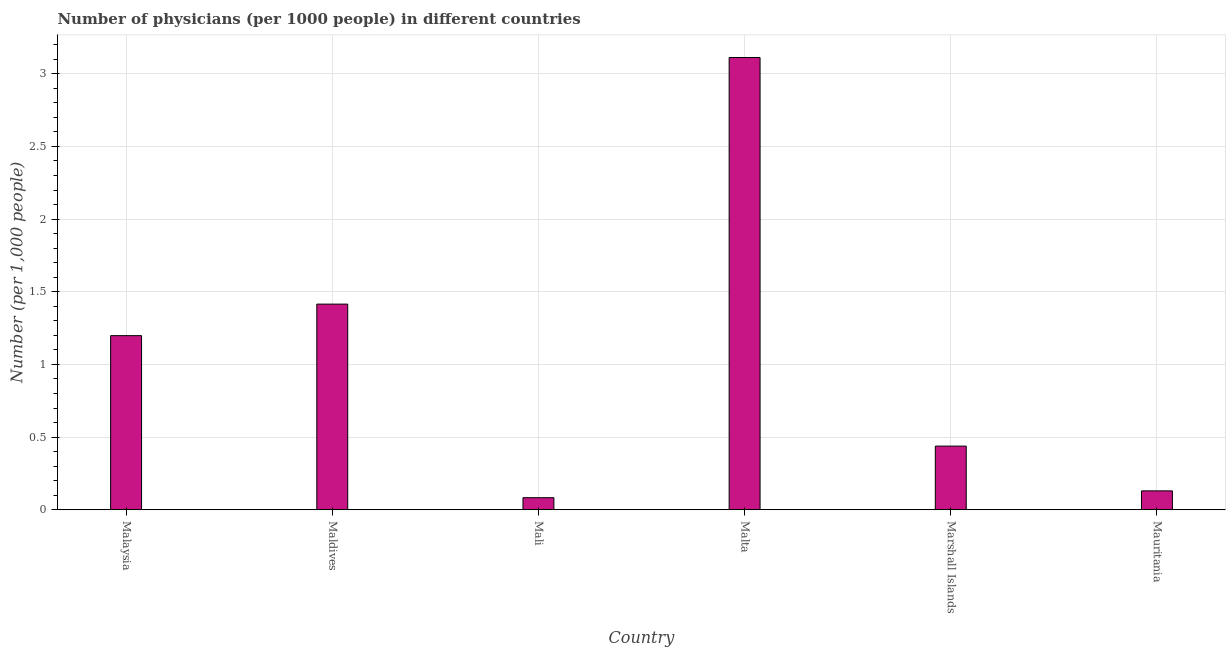Does the graph contain any zero values?
Your answer should be compact. No. What is the title of the graph?
Make the answer very short. Number of physicians (per 1000 people) in different countries. What is the label or title of the Y-axis?
Provide a succinct answer. Number (per 1,0 people). What is the number of physicians in Maldives?
Give a very brief answer. 1.42. Across all countries, what is the maximum number of physicians?
Your response must be concise. 3.11. Across all countries, what is the minimum number of physicians?
Your answer should be compact. 0.08. In which country was the number of physicians maximum?
Provide a short and direct response. Malta. In which country was the number of physicians minimum?
Provide a short and direct response. Mali. What is the sum of the number of physicians?
Make the answer very short. 6.38. What is the difference between the number of physicians in Mali and Malta?
Make the answer very short. -3.03. What is the average number of physicians per country?
Your answer should be very brief. 1.06. What is the median number of physicians?
Offer a terse response. 0.82. In how many countries, is the number of physicians greater than 2.8 ?
Your answer should be compact. 1. What is the ratio of the number of physicians in Marshall Islands to that in Mauritania?
Provide a short and direct response. 3.37. Is the difference between the number of physicians in Maldives and Mali greater than the difference between any two countries?
Keep it short and to the point. No. What is the difference between the highest and the second highest number of physicians?
Keep it short and to the point. 1.7. What is the difference between the highest and the lowest number of physicians?
Your answer should be very brief. 3.03. Are the values on the major ticks of Y-axis written in scientific E-notation?
Offer a terse response. No. What is the Number (per 1,000 people) of Malaysia?
Give a very brief answer. 1.2. What is the Number (per 1,000 people) of Maldives?
Your answer should be compact. 1.42. What is the Number (per 1,000 people) in Mali?
Provide a short and direct response. 0.08. What is the Number (per 1,000 people) in Malta?
Give a very brief answer. 3.11. What is the Number (per 1,000 people) in Marshall Islands?
Your answer should be compact. 0.44. What is the Number (per 1,000 people) of Mauritania?
Your answer should be very brief. 0.13. What is the difference between the Number (per 1,000 people) in Malaysia and Maldives?
Make the answer very short. -0.22. What is the difference between the Number (per 1,000 people) in Malaysia and Mali?
Make the answer very short. 1.11. What is the difference between the Number (per 1,000 people) in Malaysia and Malta?
Keep it short and to the point. -1.91. What is the difference between the Number (per 1,000 people) in Malaysia and Marshall Islands?
Your answer should be compact. 0.76. What is the difference between the Number (per 1,000 people) in Malaysia and Mauritania?
Keep it short and to the point. 1.07. What is the difference between the Number (per 1,000 people) in Maldives and Mali?
Your answer should be compact. 1.33. What is the difference between the Number (per 1,000 people) in Maldives and Malta?
Your response must be concise. -1.7. What is the difference between the Number (per 1,000 people) in Maldives and Marshall Islands?
Offer a terse response. 0.98. What is the difference between the Number (per 1,000 people) in Maldives and Mauritania?
Provide a short and direct response. 1.28. What is the difference between the Number (per 1,000 people) in Mali and Malta?
Make the answer very short. -3.03. What is the difference between the Number (per 1,000 people) in Mali and Marshall Islands?
Keep it short and to the point. -0.35. What is the difference between the Number (per 1,000 people) in Mali and Mauritania?
Provide a succinct answer. -0.05. What is the difference between the Number (per 1,000 people) in Malta and Marshall Islands?
Give a very brief answer. 2.67. What is the difference between the Number (per 1,000 people) in Malta and Mauritania?
Provide a succinct answer. 2.98. What is the difference between the Number (per 1,000 people) in Marshall Islands and Mauritania?
Keep it short and to the point. 0.31. What is the ratio of the Number (per 1,000 people) in Malaysia to that in Maldives?
Make the answer very short. 0.85. What is the ratio of the Number (per 1,000 people) in Malaysia to that in Mali?
Provide a succinct answer. 14.43. What is the ratio of the Number (per 1,000 people) in Malaysia to that in Malta?
Make the answer very short. 0.39. What is the ratio of the Number (per 1,000 people) in Malaysia to that in Marshall Islands?
Keep it short and to the point. 2.73. What is the ratio of the Number (per 1,000 people) in Malaysia to that in Mauritania?
Provide a succinct answer. 9.21. What is the ratio of the Number (per 1,000 people) in Maldives to that in Mali?
Provide a succinct answer. 17.05. What is the ratio of the Number (per 1,000 people) in Maldives to that in Malta?
Give a very brief answer. 0.46. What is the ratio of the Number (per 1,000 people) in Maldives to that in Marshall Islands?
Your response must be concise. 3.23. What is the ratio of the Number (per 1,000 people) in Maldives to that in Mauritania?
Ensure brevity in your answer.  10.88. What is the ratio of the Number (per 1,000 people) in Mali to that in Malta?
Your response must be concise. 0.03. What is the ratio of the Number (per 1,000 people) in Mali to that in Marshall Islands?
Make the answer very short. 0.19. What is the ratio of the Number (per 1,000 people) in Mali to that in Mauritania?
Ensure brevity in your answer.  0.64. What is the ratio of the Number (per 1,000 people) in Malta to that in Marshall Islands?
Offer a terse response. 7.11. What is the ratio of the Number (per 1,000 people) in Malta to that in Mauritania?
Your answer should be compact. 23.94. What is the ratio of the Number (per 1,000 people) in Marshall Islands to that in Mauritania?
Make the answer very short. 3.37. 